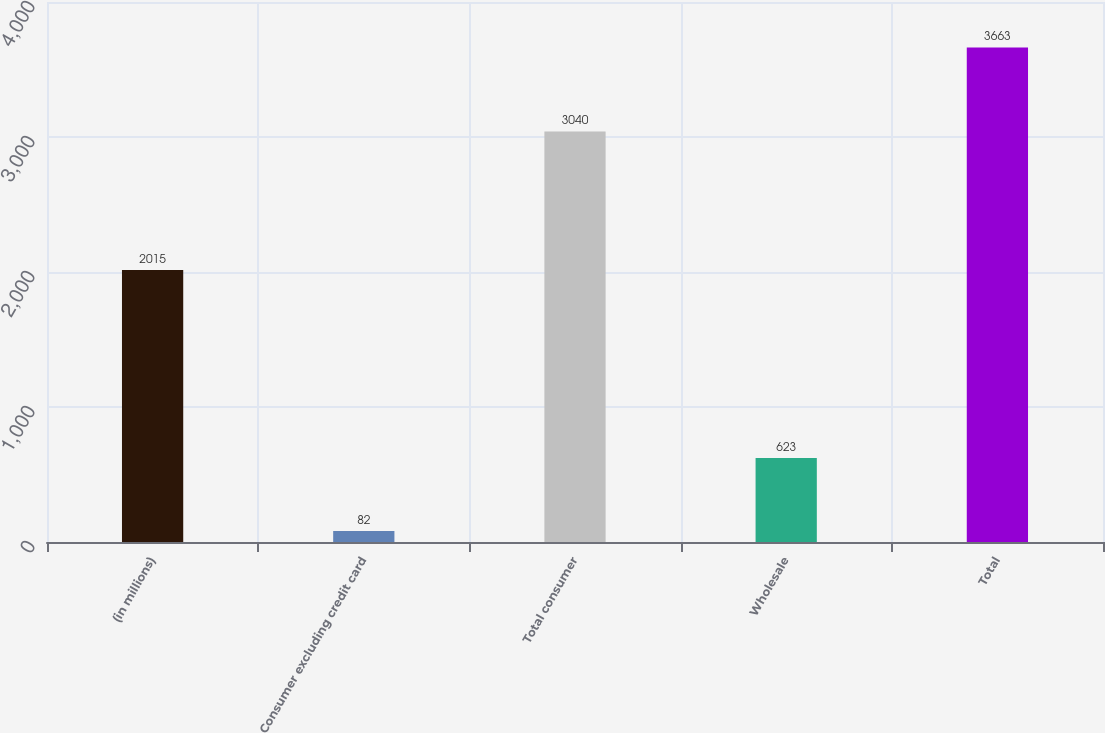Convert chart. <chart><loc_0><loc_0><loc_500><loc_500><bar_chart><fcel>(in millions)<fcel>Consumer excluding credit card<fcel>Total consumer<fcel>Wholesale<fcel>Total<nl><fcel>2015<fcel>82<fcel>3040<fcel>623<fcel>3663<nl></chart> 